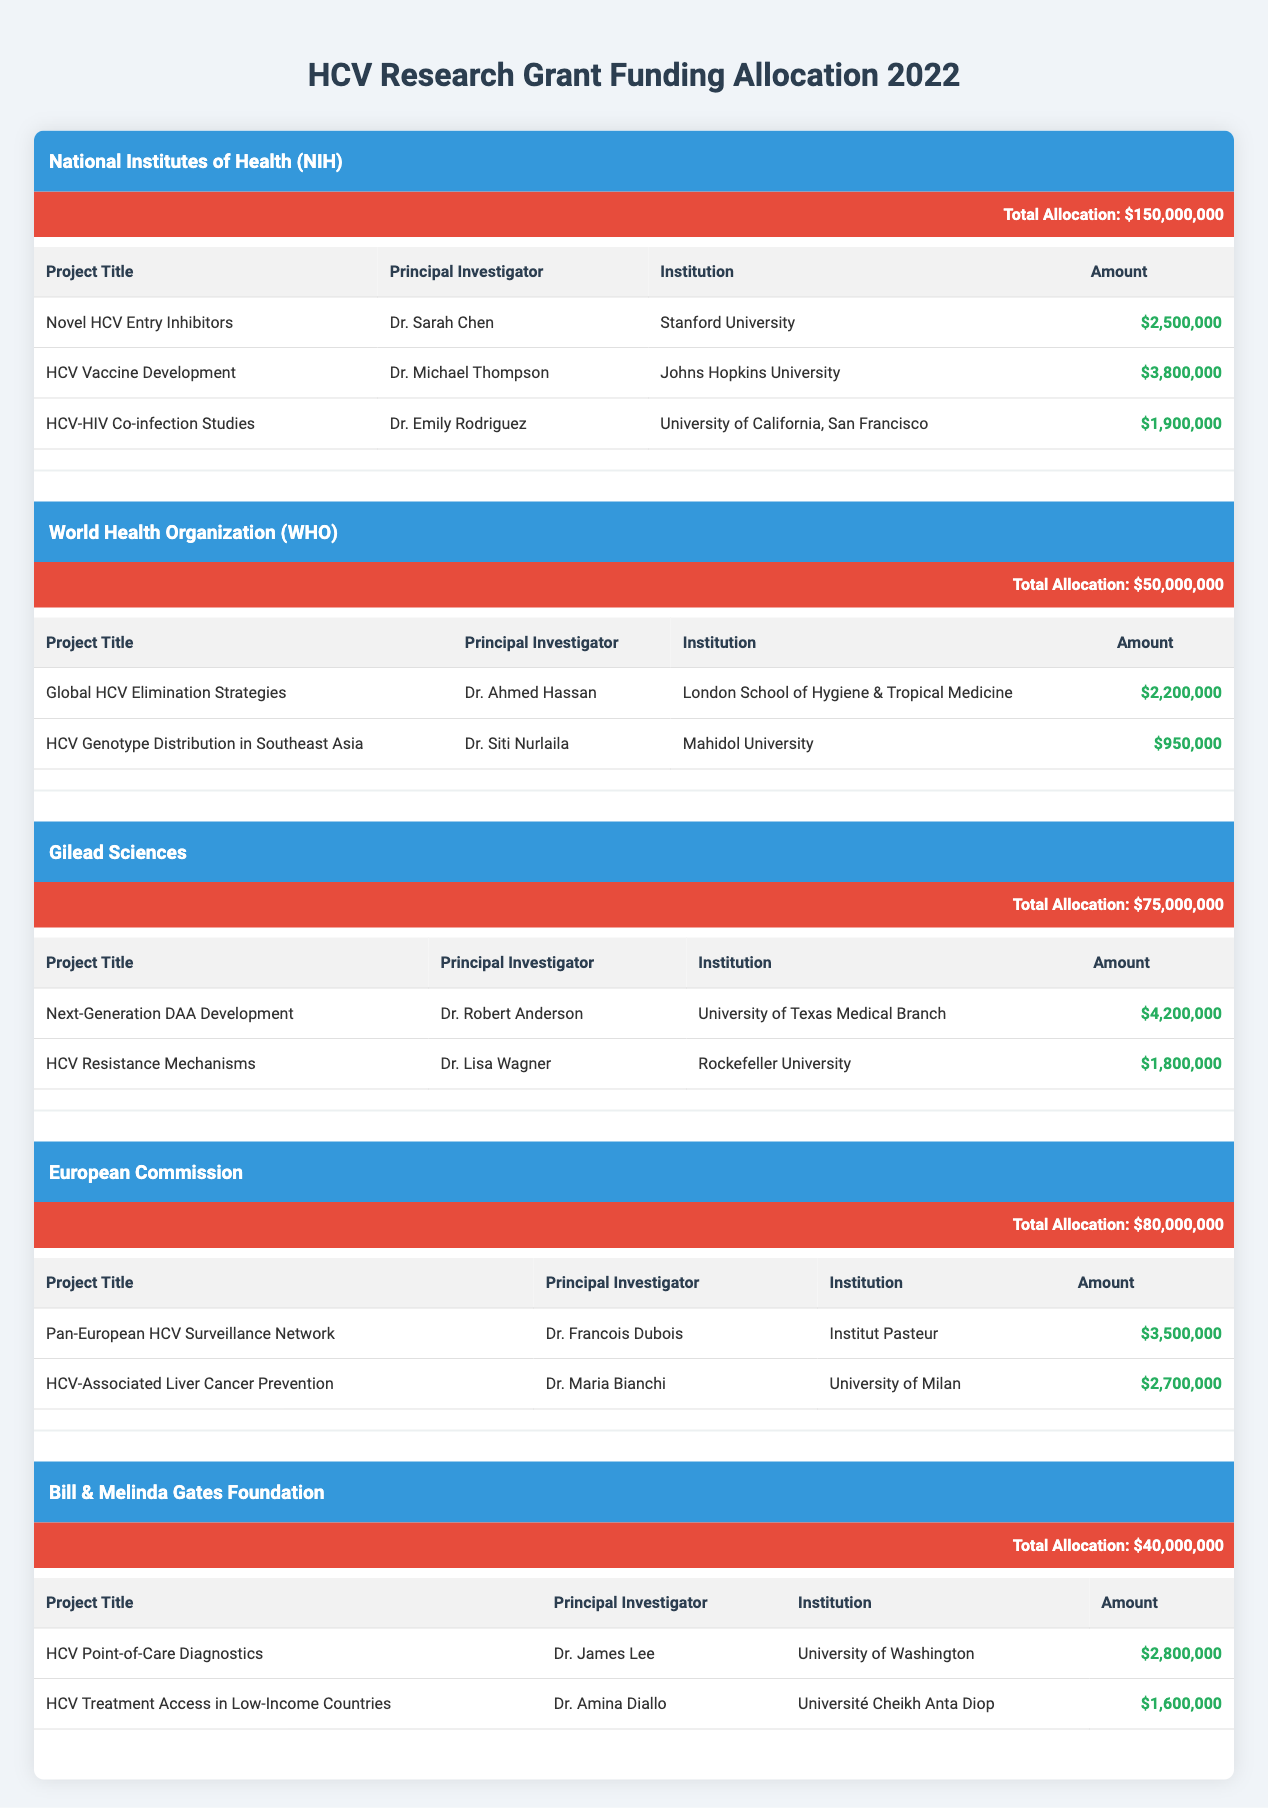What is the total funding allocated by the National Institutes of Health? The total funding allocated by the National Institutes of Health (NIH) is listed in the table under their respective section, which states a total allocation of 150,000,000 dollars.
Answer: 150000000 Which project received the highest amount from Gilead Sciences? To find the project with the highest amount from Gilead Sciences, we compare the amounts allocated to each project under their section. The project "Next-Generation DAA Development" received 4,200,000 dollars, which is greater than the other project amount of 1,800,000 dollars.
Answer: Next-Generation DAA Development Is there a project titled "HCV Vaccine Development"? The table lists the project titles for the funding source NIH, and it includes "HCV Vaccine Development" as one of the projects. Therefore, this project exists.
Answer: Yes What is the combined total funding for WHO projects? There are two projects funded by the World Health Organization (WHO): "Global HCV Elimination Strategies" which received 2,200,000 dollars and "HCV Genotype Distribution in Southeast Asia" which received 950,000 dollars. Adding these amounts gives a combined total of 2,200,000 + 950,000 = 3,150,000 dollars.
Answer: 3150000 Which institution received the least funding overall? To determine which institution received the least funding overall, we look at all projects across all funding sources and compare the allocated amounts. The smallest amount is 950,000 dollars allocated to Mahidol University for the project "HCV Genotype Distribution in Southeast Asia."
Answer: Mahidol University How much total funding did Gilead Sciences allocate? Gilead Sciences allocated two project amounts: "Next-Generation DAA Development" received 4,200,000 dollars and "HCV Resistance Mechanisms" received 1,800,000 dollars. To find the total, we add these two amounts: 4,200,000 + 1,800,000 = 6,000,000 dollars.
Answer: 6000000 Is the total funding from the European Commission greater than that from Gilead Sciences? The total funding from the European Commission is 80,000,000 dollars and from Gilead Sciences is 75,000,000 dollars. Since 80,000,000 is greater than 75,000,000, we can conclude that this statement is true.
Answer: Yes What is the average funding per project for the Bill & Melinda Gates Foundation? The total funding allocated by the Bill & Melinda Gates Foundation is 40,000,000 dollars across two projects: "HCV Point-of-Care Diagnostics" and "HCV Treatment Access in Low-Income Countries." To find the average funding, we first calculate the total number of projects (2), and then divide the total funding by the number of projects: 40,000,000 / 2 = 20,000,000 dollars.
Answer: 20000000 What percentage of total funding is allocated by the World Health Organization compared to the total funding of all sources combined? The total funding allocations from all listed sources are: NIH (150,000,000), WHO (50,000,000), Gilead (75,000,000), European Commission (80,000,000), and Gates Foundation (40,000,000), totaling 395,000,000 dollars. The funding from WHO is 50,000,000. To find the percentage, we calculate (50,000,000 / 395,000,000) * 100, which equals approximately 12.66%.
Answer: 12.66 